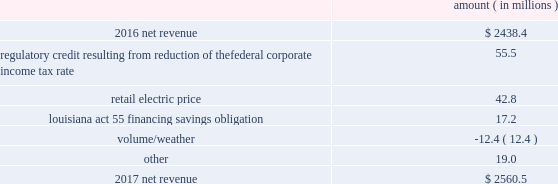Entergy louisiana , llc and subsidiaries management 2019s financial discussion and analysis results of operations net income 2017 compared to 2016 net income decreased $ 305.7 million primarily due to the effect of the enactment of the tax cuts and jobs act , in december 2017 , which resulted in a decrease of $ 182.6 million in net income in 2017 , and the effect of a settlement with the irs related to the 2010-2011 irs audit , which resulted in a $ 136.1 million reduction of income tax expense in 2016 .
Also contributing to the decrease in net income were higher other operation and maintenance expenses .
The decrease was partially offset by higher net revenue and higher other income .
See note 3 to the financial statements for discussion of the effects of the tax cuts and jobs act and the irs audit .
2016 compared to 2015 net income increased $ 175.4 million primarily due to the effect of a settlement with the irs related to the 2010-2011 irs audit , which resulted in a $ 136.1 million reduction of income tax expense in 2016 .
Also contributing to the increase were lower other operation and maintenance expenses , higher net revenue , and higher other income .
The increase was partially offset by higher depreciation and amortization expenses , higher interest expense , and higher nuclear refueling outage expenses .
See note 3 to the financial statements for discussion of the irs audit .
Net revenue 2017 compared to 2016 net revenue consists of operating revenues net of : 1 ) fuel , fuel-related expenses , and gas purchased for resale , 2 ) purchased power expenses , and 3 ) other regulatory charges ( credits ) .
Following is an analysis of the change in net revenue comparing 2017 to 2016 .
Amount ( in millions ) .
The regulatory credit resulting from reduction of the federal corporate income tax rate variance is due to the reduction of the vidalia purchased power agreement regulatory liability by $ 30.5 million and the reduction of the louisiana act 55 financing savings obligation regulatory liabilities by $ 25 million as a result of the enactment of the tax cuts and jobs act , in december 2017 , which lowered the federal corporate income tax rate from 35% ( 35 % ) to 21% ( 21 % ) .
The effects of the tax cuts and jobs act are discussed further in note 3 to the financial statements. .
In 2017 what was the percentage change in the net revenue? 
Computations: ((2560.5 - 2438.4) / 2438.4)
Answer: 0.05007. 